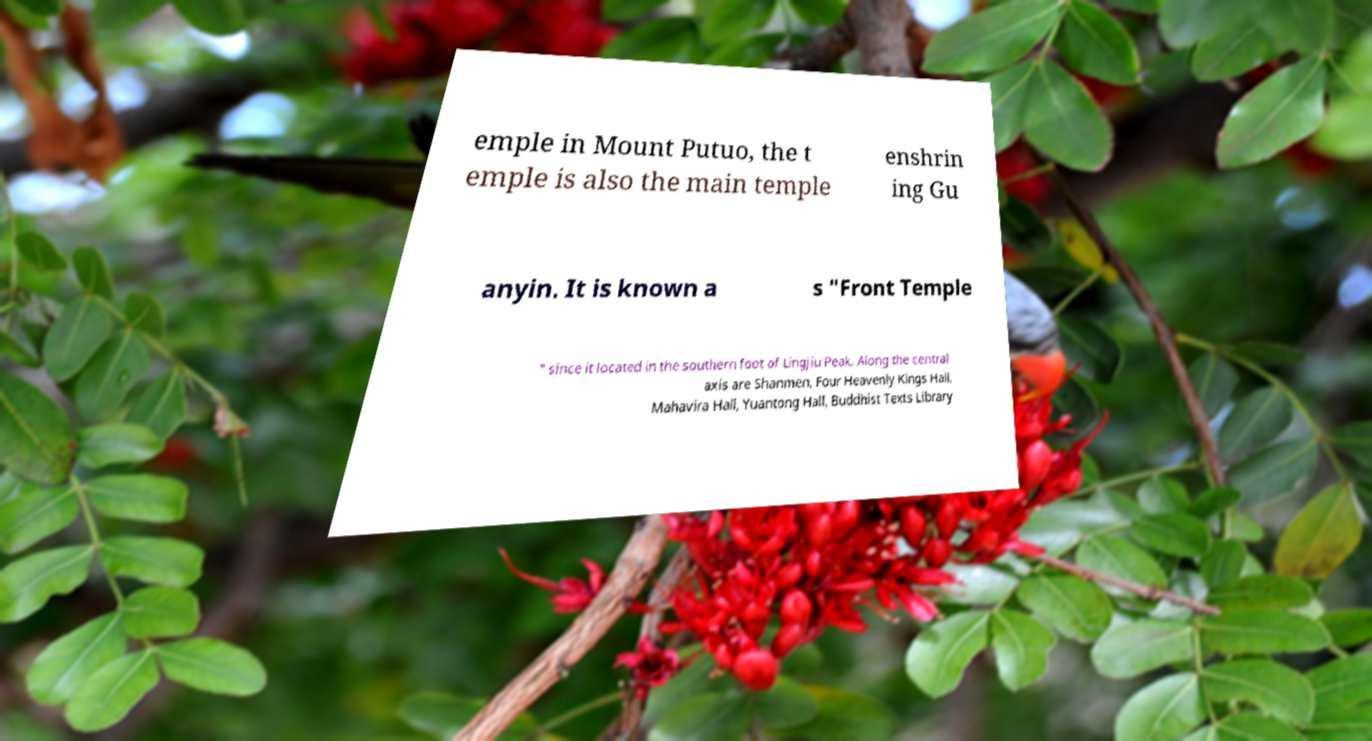Could you assist in decoding the text presented in this image and type it out clearly? emple in Mount Putuo, the t emple is also the main temple enshrin ing Gu anyin. It is known a s "Front Temple " since it located in the southern foot of Lingjiu Peak. Along the central axis are Shanmen, Four Heavenly Kings Hall, Mahavira Hall, Yuantong Hall, Buddhist Texts Library 